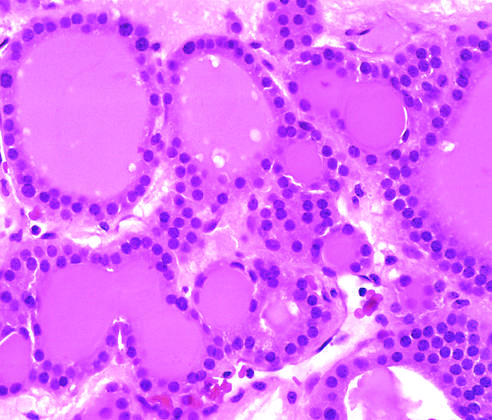s a solitary, well-circumscribed nodule visible in this gross specimen?
Answer the question using a single word or phrase. Yes 